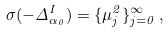Convert formula to latex. <formula><loc_0><loc_0><loc_500><loc_500>\sigma ( - \Delta _ { \alpha _ { 0 } } ^ { I } ) = \{ \mu _ { j } ^ { 2 } \} _ { j = 0 } ^ { \infty } \, ,</formula> 